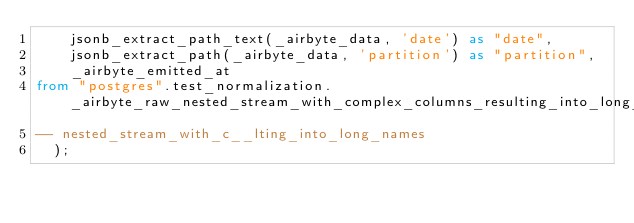Convert code to text. <code><loc_0><loc_0><loc_500><loc_500><_SQL_>    jsonb_extract_path_text(_airbyte_data, 'date') as "date",
    jsonb_extract_path(_airbyte_data, 'partition') as "partition",
    _airbyte_emitted_at
from "postgres".test_normalization._airbyte_raw_nested_stream_with_complex_columns_resulting_into_long_names
-- nested_stream_with_c__lting_into_long_names
  );
</code> 